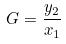<formula> <loc_0><loc_0><loc_500><loc_500>G = \frac { y _ { 2 } } { x _ { 1 } }</formula> 